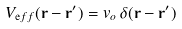<formula> <loc_0><loc_0><loc_500><loc_500>V _ { \mathrm e f f } ( { \mathbf r } - { \mathbf r ^ { \prime } } ) = v _ { o } \, \delta ( { \mathbf r } - { \mathbf r ^ { \prime } } )</formula> 